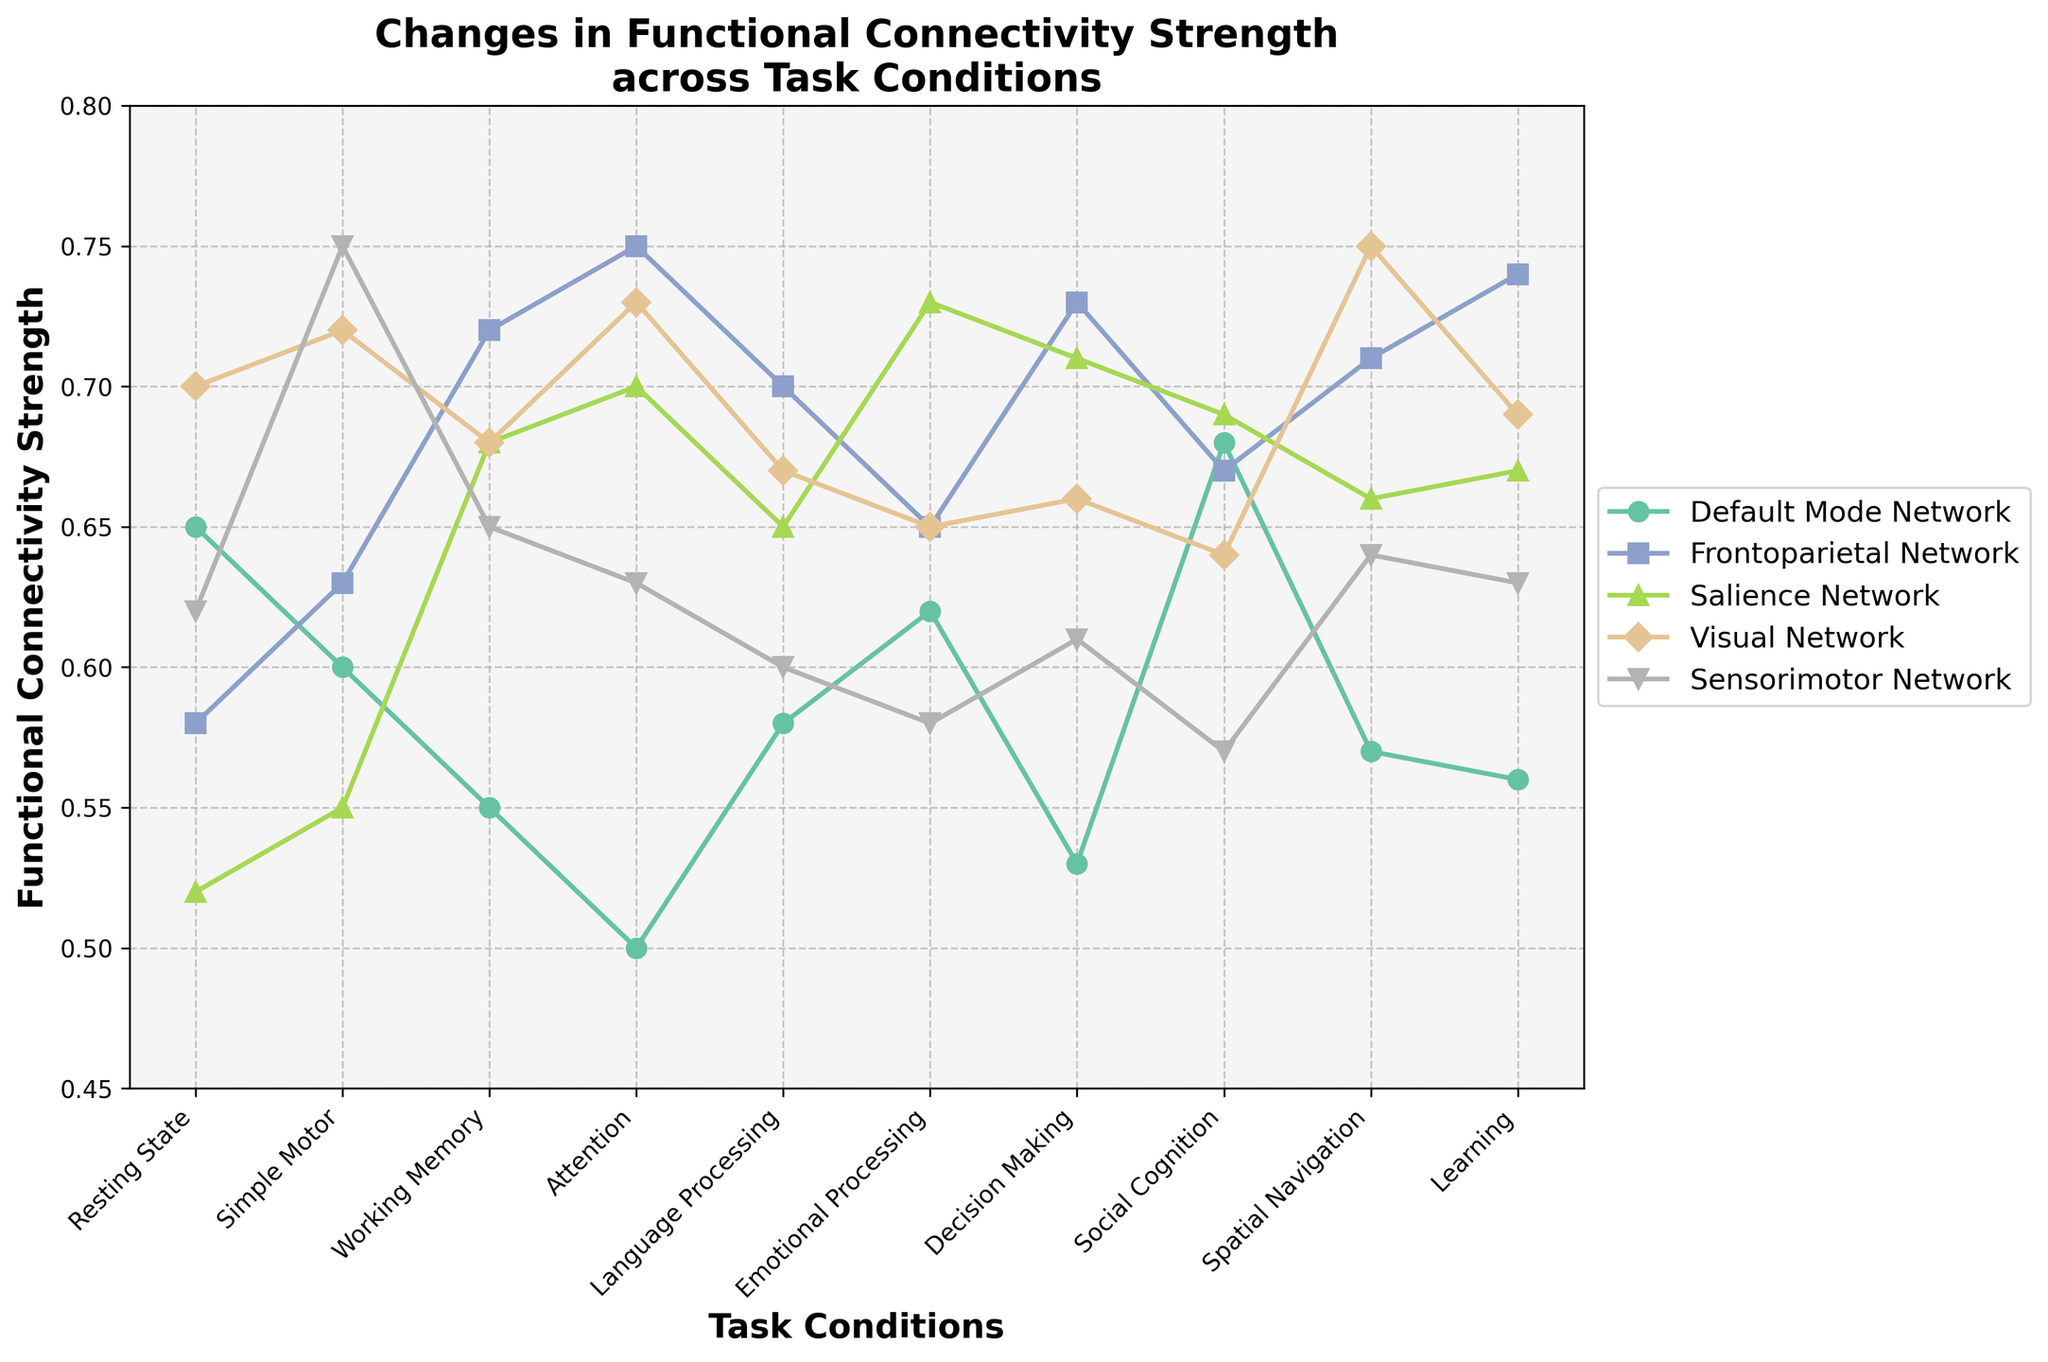Which task condition shows the highest functional connectivity strength for the Visual Network? Look at the points corresponding to the Visual Network (lines in different colors) and identify the highest value in the y-axis.
Answer: Attention Which network exhibits the most significant increase in functional connectivity strength when switching from Resting State to Simple Motor tasks? Calculate the difference between the Simple Motor and Resting State tasks for each network and compare which network has the largest increase.
Answer: Sensorimotor Network What is the average functional connectivity strength of the Salience Network across all task conditions? Sum the y-value (functional connectivity strength) for the Salience Network across all task conditions, then divide it by the number of task conditions (10).
Answer: 0.66 During which task condition do the Default Mode Network and Frontoparietal Network have equal functional connectivity strength? Compare the values of the Default Mode Network and Frontoparietal Network across different task conditions and find where they are the same.
Answer: Language Processing Which network shows the most consistent functional connectivity strength across different task conditions? Evaluate the standard deviation of connectivity values for each network. The network with the lowest standard deviation is the most consistent. (Detailed calculation required)
Answer: Visual Network During the Spatial Navigation task, which two networks have the closest functional connectivity strength? Compare the functional connectivity strengths for all networks during the Spatial Navigation task and determine which two networks have the closest values.
Answer: Salience Network and Default Mode Network Which network shows the sharpest decline in functional connectivity strength between any two consecutive task conditions? Calculate the differences between consecutive values for each network and identify the largest negative change.
Answer: Default Mode Network from Attentional to Language Processing Which task condition has the lowest functional connectivity strength for the Sensorimotor Network? Look at the data points for the Sensorimotor Network and identify the lowest value on the y-axis.
Answer: Social Cognition What is the difference in functional connectivity strength between the highest and lowest values of the Salience Network across all task conditions? Determine the highest and lowest values for the Salience Network and subtract the lowest value from the highest value.
Answer: 0.21 What is the trend of functional connectivity strength of the Frontoparietal Network from Resting State to Attention task conditions? Observe the line associated with the Frontoparietal Network from Resting State to Attention and note the direction it moves (increasing or decreasing).
Answer: Increasing 